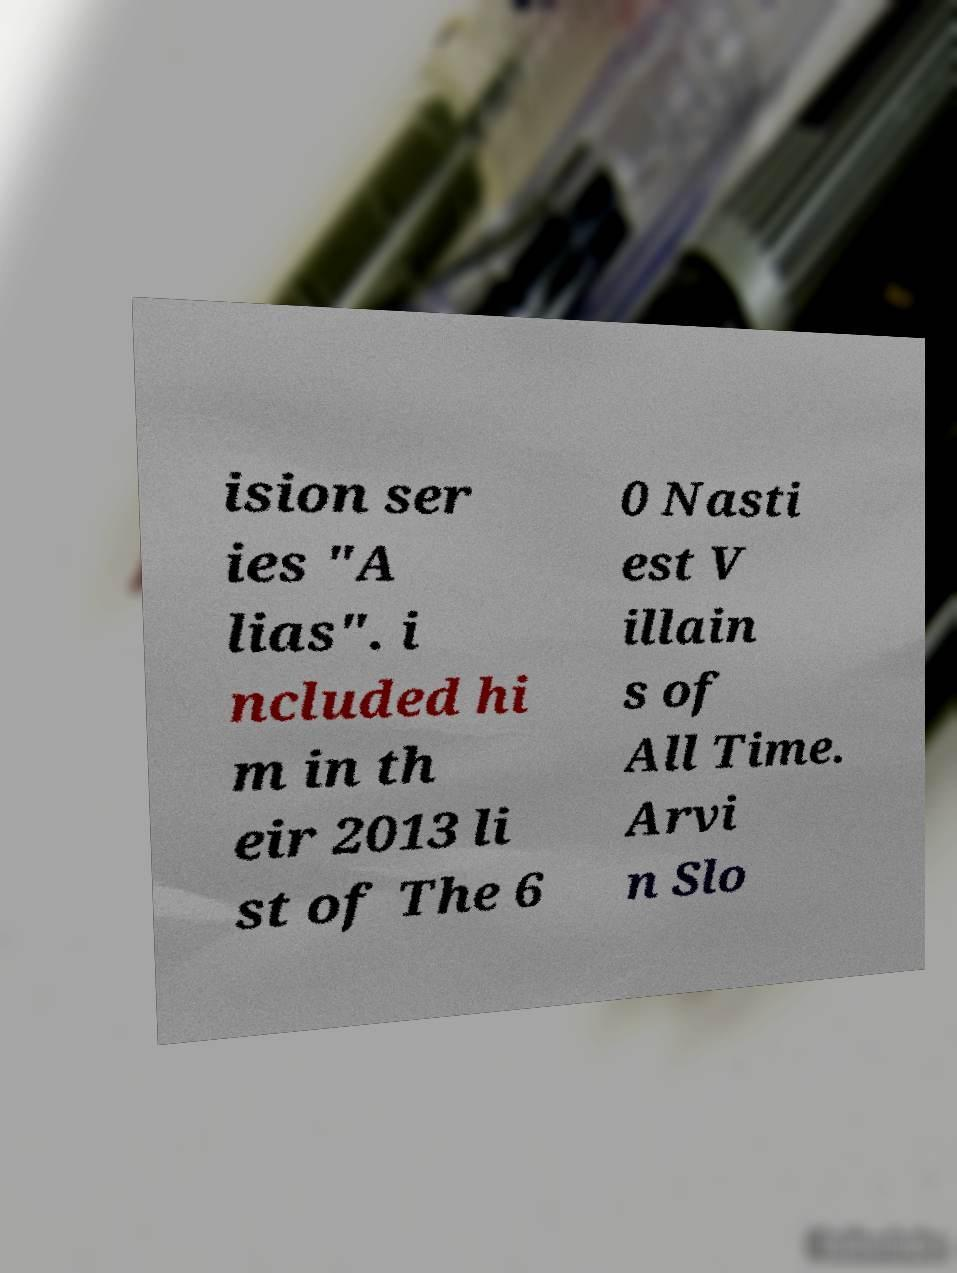Please identify and transcribe the text found in this image. ision ser ies "A lias". i ncluded hi m in th eir 2013 li st of The 6 0 Nasti est V illain s of All Time. Arvi n Slo 